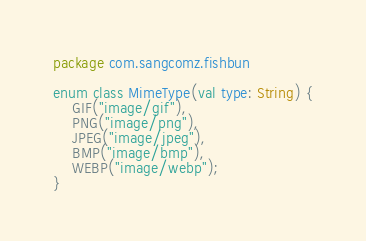Convert code to text. <code><loc_0><loc_0><loc_500><loc_500><_Kotlin_>package com.sangcomz.fishbun

enum class MimeType(val type: String) {
    GIF("image/gif"),
    PNG("image/png"),
    JPEG("image/jpeg"),
    BMP("image/bmp"),
    WEBP("image/webp");
}</code> 